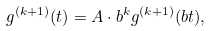<formula> <loc_0><loc_0><loc_500><loc_500>g ^ { ( k + 1 ) } ( t ) = A \cdot b ^ { k } g ^ { ( k + 1 ) } ( b t ) ,</formula> 